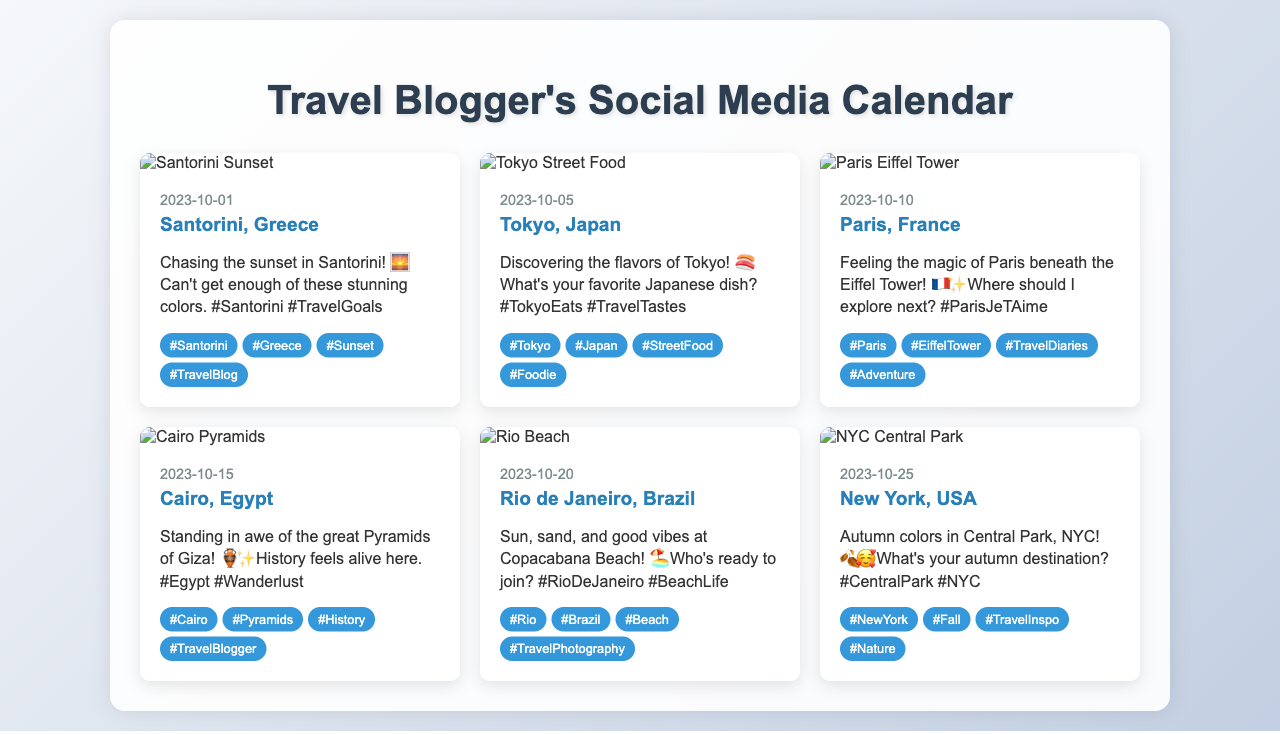What is the date of the post featuring Santorini? The post featuring Santorini is dated October 1, 2023.
Answer: October 1, 2023 What destination is featured in the post dated October 10? The post dated October 10 features Paris, France.
Answer: Paris, France How many images are in the social media calendar? There are six calendar items with one image each, totaling six images in the document.
Answer: Six What caption accompanies the post for Tokyo, Japan? The caption for the Tokyo post is "Discovering the flavors of Tokyo! 🍣 What's your favorite Japanese dish? #TokyoEats #TravelTastes".
Answer: Discovering the flavors of Tokyo! 🍣 What's your favorite Japanese dish? #TokyoEats #TravelTastes Which destination has the hashtag #EiffelTower? The destination with the hashtag #EiffelTower is Paris, France.
Answer: Paris, France On which date is the post about Rio de Janeiro scheduled? The post about Rio de Janeiro is scheduled for October 20, 2023.
Answer: October 20, 2023 What are the hashtags used in the Cairo, Egypt post? The hashtags in the Cairo post are #Cairo, #Pyramids, #History, and #TravelBlogger.
Answer: #Cairo, #Pyramids, #History, #TravelBlogger Which city is featured with autumn colors in the calendar? The city featured with autumn colors is New York, USA.
Answer: New York, USA What is the theme of the caption for the post featuring the Eiffel Tower? The theme of the caption for the Eiffel Tower post revolves around the magic of Paris and exploring new places.
Answer: The magic of Paris and exploring new places 